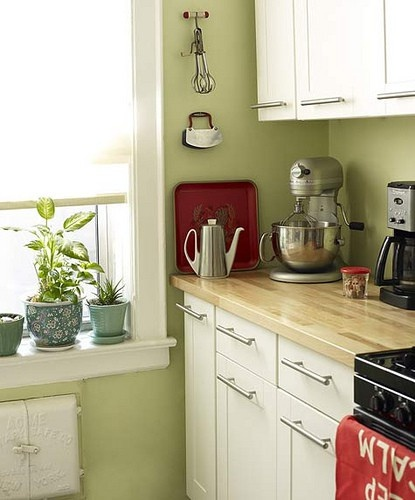Describe the objects in this image and their specific colors. I can see potted plant in white, ivory, gray, khaki, and olive tones, oven in white, black, gray, and darkgray tones, bowl in white, olive, black, and gray tones, potted plant in white, gray, darkgray, and ivory tones, and potted plant in white, darkgreen, ivory, and darkgray tones in this image. 